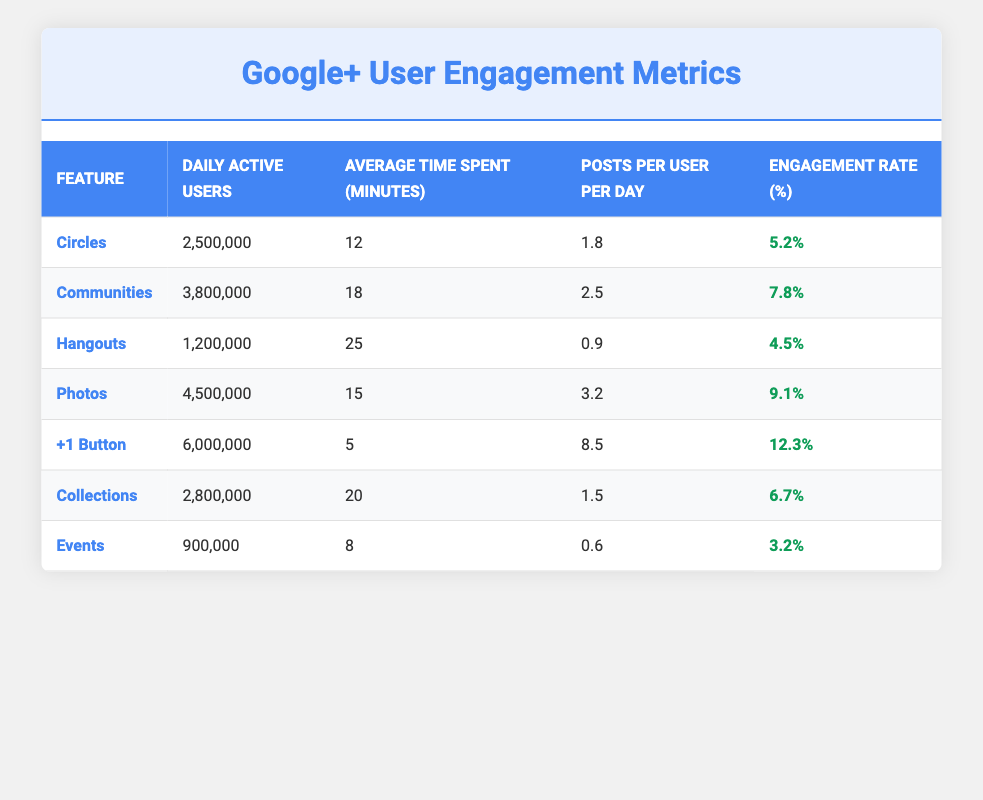What is the engagement rate for the Photos feature? The engagement rate for the Photos feature can be found in the corresponding row of the table. It shows that the engagement rate is 9.1%.
Answer: 9.1% How many daily active users does the +1 Button have? The daily active users for the +1 Button are listed in the table under that feature, totaling 6,000,000.
Answer: 6,000,000 Which feature has the highest average time spent by users? To determine this, we can compare the average time spent across all features. Hangouts has the highest average time spent at 25 minutes.
Answer: Hangouts What is the total number of daily active users for Communities and Photos combined? To find this total, we add the daily active users for Communities (3,800,000) and Photos (4,500,000): 3,800,000 + 4,500,000 = 8,300,000.
Answer: 8,300,000 Is the engagement rate for Events higher than that of Circles? By comparing the engagement rates from the table, Events has an engagement rate of 3.2%, while Circles has 5.2%. Since 3.2% is less than 5.2%, the statement is false.
Answer: No What is the average daily active users across all features? We calculate the average by summing all daily active users (2,500,000 + 3,800,000 + 1,200,000 + 4,500,000 + 6,000,000 + 2,800,000 + 900,000 = 21,700,000) and dividing by the number of features (7): 21,700,000 / 7 = 3,100,000.
Answer: 3,100,000 Which feature has the lowest posts per user per day? We can find the lowest posts per user per day by checking the relevant column values. Hangouts has the lowest value at 0.9 posts per user per day.
Answer: Hangouts What is the difference in engagement rates between the +1 Button and Communities? To find this difference, we subtract the engagement rate of Communities (7.8%) from that of the +1 Button (12.3%): 12.3% - 7.8% = 4.5%.
Answer: 4.5% Which feature has the second highest number of daily active users? To figure this out, we can list daily active users from highest to lowest. The second highest value is for Photos with 4,500,000 daily active users.
Answer: Photos 